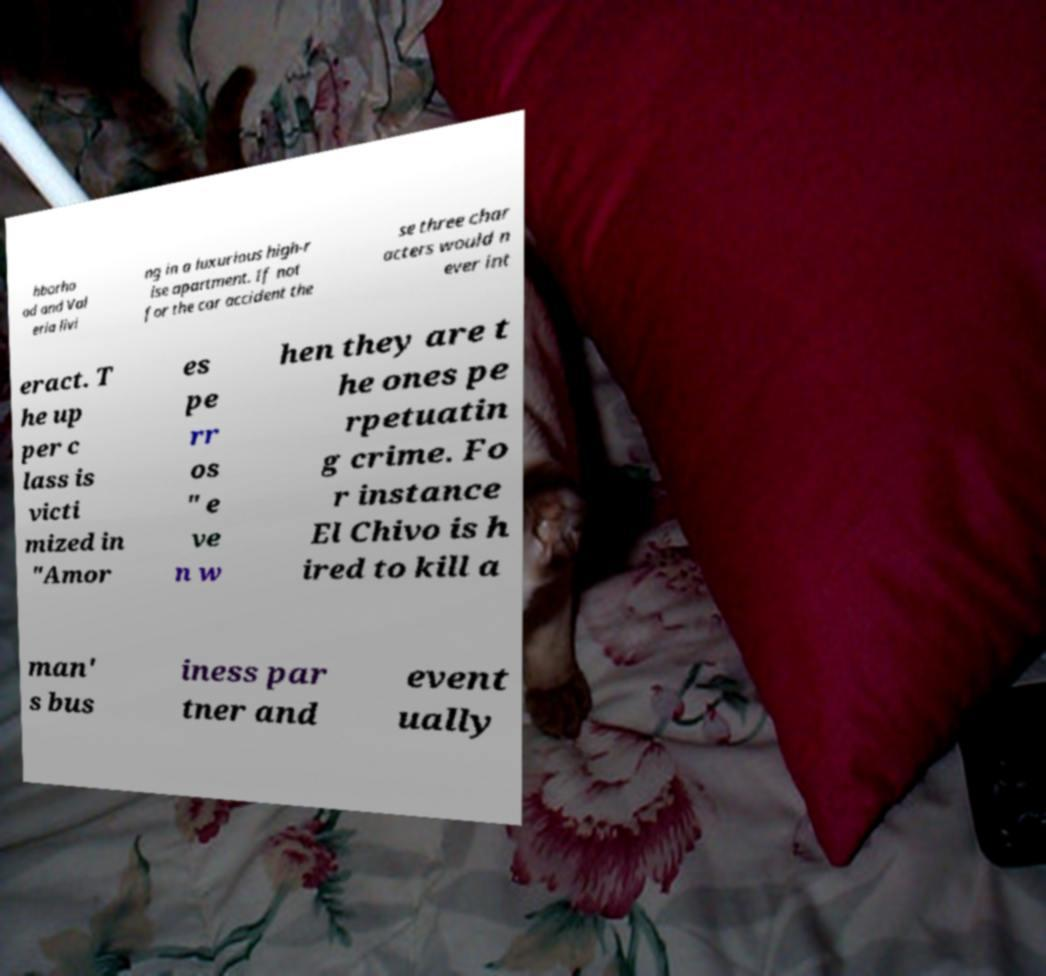I need the written content from this picture converted into text. Can you do that? hborho od and Val eria livi ng in a luxurious high-r ise apartment. If not for the car accident the se three char acters would n ever int eract. T he up per c lass is victi mized in "Amor es pe rr os " e ve n w hen they are t he ones pe rpetuatin g crime. Fo r instance El Chivo is h ired to kill a man' s bus iness par tner and event ually 